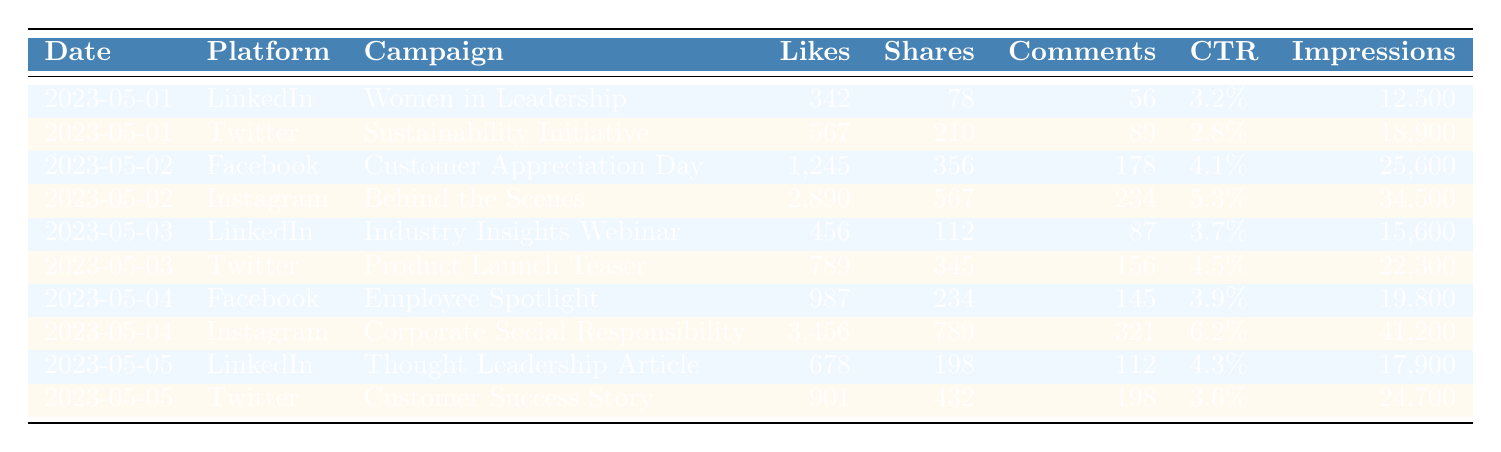What was the highest number of Likes received on a single day? By examining the data, we can identify that on May 2, the Instagram campaign "Behind the Scenes" received the highest number of Likes, totaling 2890.
Answer: 2890 Which platform had the highest Click-through Rate (CTR) overall? The highest CTR is associated with the Instagram campaign "Corporate Social Responsibility," which recorded a rate of 6.2%.
Answer: Instagram What was the total number of Shares across all campaigns on May 3? Adding the Shares for both campaigns on May 3 gives us 112 (LinkedIn) + 345 (Twitter) = 457.
Answer: 457 Did any campaign on Facebook exceed 1,000 Likes? Yes, the Facebook campaign "Customer Appreciation Day" on May 2 received 1245 Likes, which is over 1,000.
Answer: Yes What is the average number of Comments on the Twitter campaigns across all days? The Comments for Twitter are 89 (May 1) + 156 (May 3) + 198 (May 5) = 443; dividing by 3 gives an average of 443/3 = 147.67.
Answer: 147.67 Which day had the lowest number of Impressions, and what was the figure? The data indicates that on May 1, Twitter had the lowest Impressions of 18,900.
Answer: May 1, 18,900 What is the total number of Likes from the campaigns on LinkedIn? Summing the Likes for LinkedIn, we have 342 (May 1) + 456 (May 3) + 678 (May 5) = 1476 Likes in total.
Answer: 1476 Was the "Women in Leadership" campaign effective in generating interactions (Likes, Shares, Comments)? Yes, the campaign had 342 Likes, 78 Shares, and 56 Comments, showing considerable interaction.
Answer: Yes Which campaign had the highest engagement in terms of Likes, Shares, and Comments combined? The Instagram campaign "Corporate Social Responsibility" on May 4 had a sum of 3456 (Likes) + 789 (Shares) + 321 (Comments) = 4566, the highest engagement metric.
Answer: Corporate Social Responsibility What is the difference in the number of Likes between the Instagram campaign and the Facebook campaign on May 4? The Instagram campaign had 3456 Likes, and the Facebook campaign had 987 Likes; the difference is 3456 - 987 = 2469.
Answer: 2469 